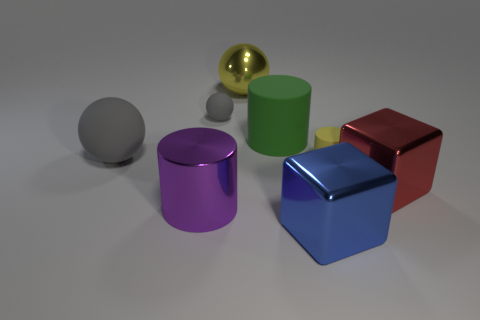Subtract all large rubber cylinders. How many cylinders are left? 2 Subtract all green cylinders. How many cylinders are left? 2 Subtract all blocks. How many objects are left? 6 Add 1 big brown metal things. How many objects exist? 9 Subtract 3 cylinders. How many cylinders are left? 0 Add 1 small yellow matte balls. How many small yellow matte balls exist? 1 Subtract 1 yellow spheres. How many objects are left? 7 Subtract all brown cylinders. Subtract all cyan spheres. How many cylinders are left? 3 Subtract all yellow cylinders. How many gray balls are left? 2 Subtract all large purple objects. Subtract all large green cylinders. How many objects are left? 6 